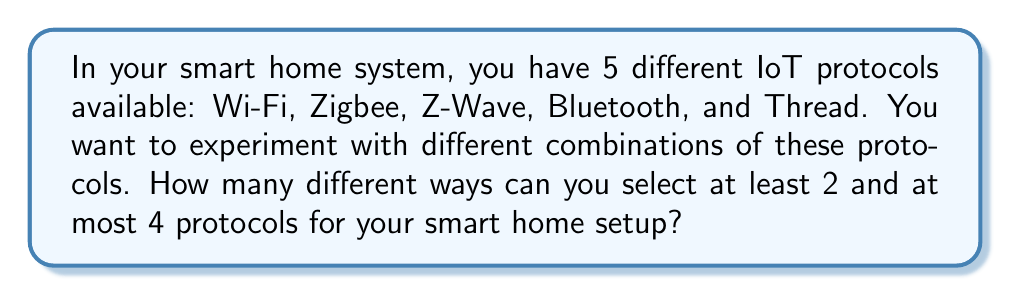Teach me how to tackle this problem. Let's approach this step-by-step using the principles of combinatorics:

1) We need to find the sum of the number of ways to select 2, 3, and 4 protocols out of 5.

2) For selecting 2 protocols out of 5:
   We use the combination formula: $${5 \choose 2} = \frac{5!}{2!(5-2)!} = \frac{5 \cdot 4}{2 \cdot 1} = 10$$

3) For selecting 3 protocols out of 5:
   $${5 \choose 3} = \frac{5!}{3!(5-3)!} = \frac{5 \cdot 4 \cdot 3}{3 \cdot 2 \cdot 1} = 10$$

4) For selecting 4 protocols out of 5:
   $${5 \choose 4} = \frac{5!}{4!(5-4)!} = \frac{5}{1} = 5$$

5) The total number of ways is the sum of these combinations:
   $$\text{Total} = {5 \choose 2} + {5 \choose 3} + {5 \choose 4} = 10 + 10 + 5 = 25$$

Therefore, there are 25 different ways to select at least 2 and at most 4 protocols for your smart home setup.
Answer: 25 